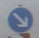Are there any environmental or contextual elements in the image that hint at other nearby traffic signs or road conditions that might not be clearly visible? The surrounding environment and the background may suggest a heavily trafficked area, possibly an urban setting or a busy intersection. Sometimes the wear or weathering on a sign, visible branches, or light reflections can indicate the presence of trees or street lights that might not be clearly visible. These elements can help infer other potential road conditions like crosswalks, junctions, or additional signs that mandate caution.  What potential consequences could arise from misinterpreting the visible traffic signs in this image? Misinterpreting traffic signs can lead to serious road safety risks, including accidents and traffic violations. For instance, failing to recognize a 'Speed limit' sign may result in speeding, while overlooking a 'No Entry' sign can cause driving in the wrong direction. Ensuring accurate interpretation and adherence to these signs is crucial for maintaining traffic order and safety. 